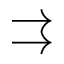<formula> <loc_0><loc_0><loc_500><loc_500>\right r i g h t a r r o w s</formula> 